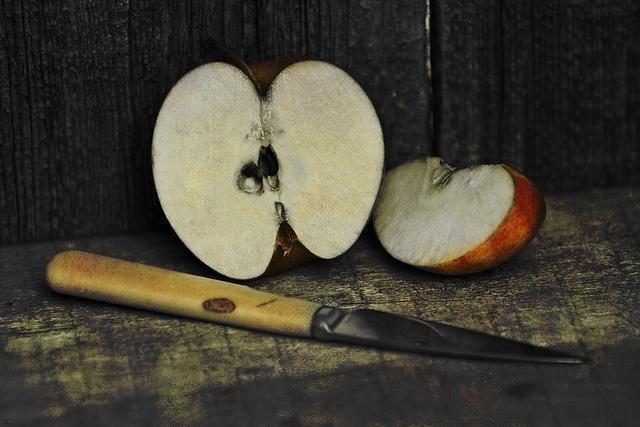How many apples are there?
Give a very brief answer. 2. 